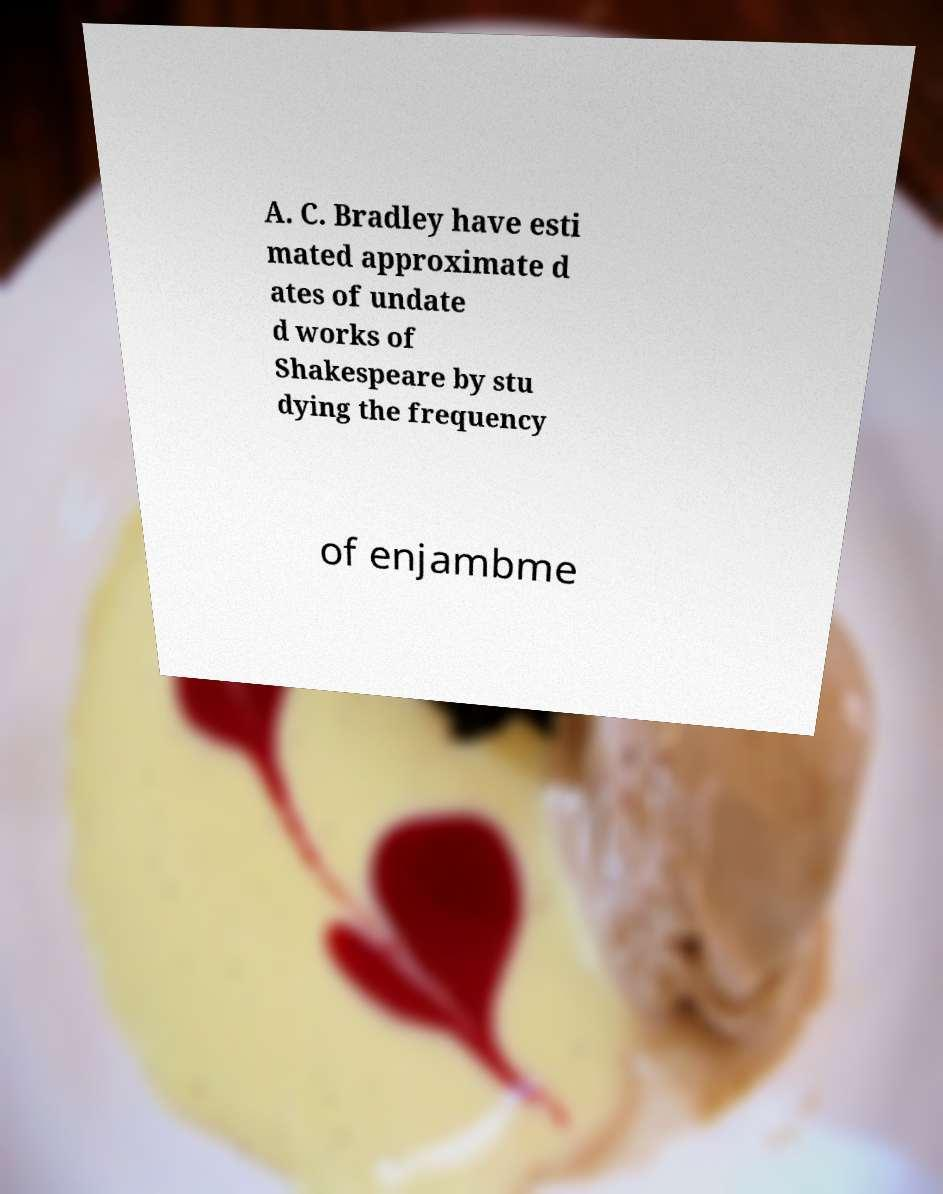Please identify and transcribe the text found in this image. A. C. Bradley have esti mated approximate d ates of undate d works of Shakespeare by stu dying the frequency of enjambme 